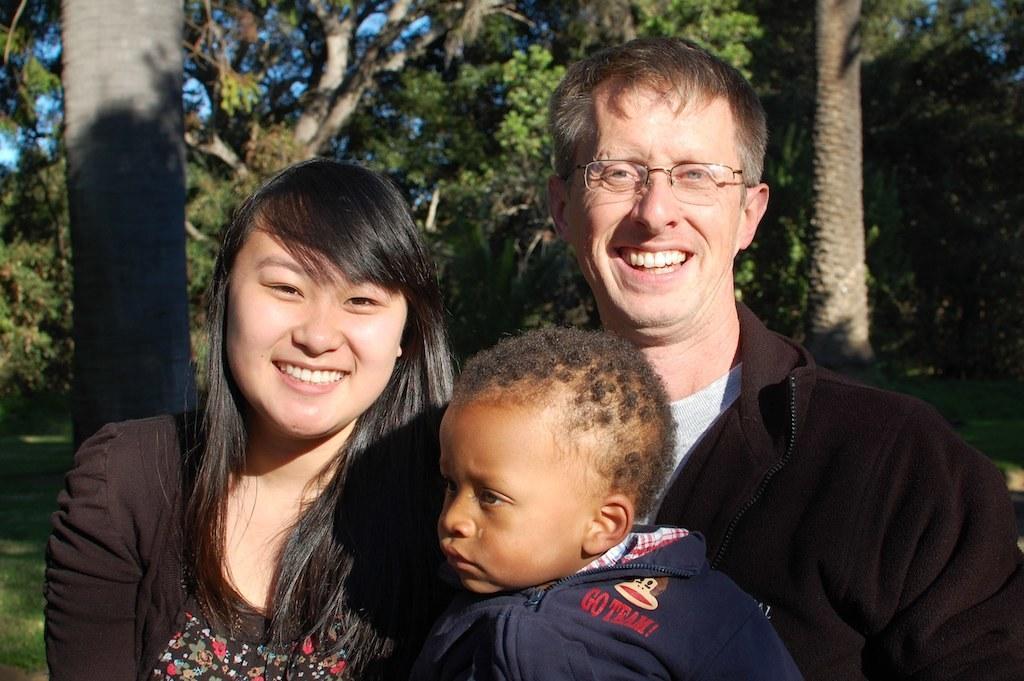Describe this image in one or two sentences. In this image, I can see a man and a woman smiling. I can see a boy. In the background, there are trees. 